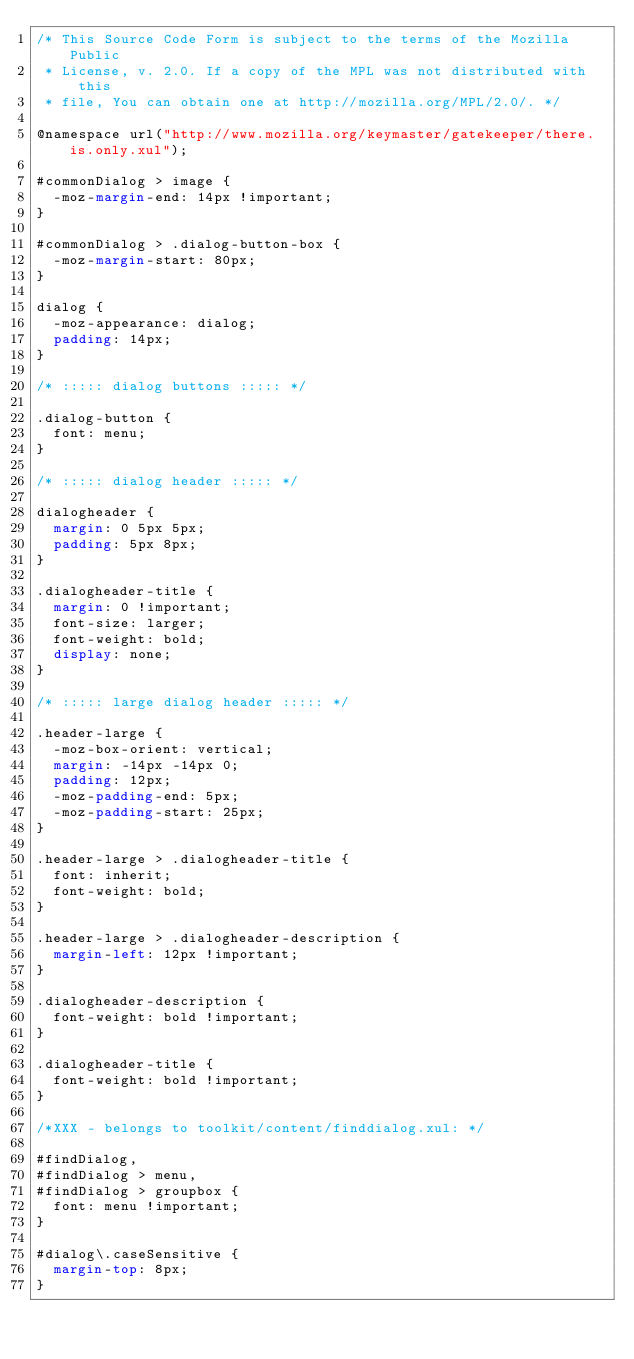<code> <loc_0><loc_0><loc_500><loc_500><_CSS_>/* This Source Code Form is subject to the terms of the Mozilla Public
 * License, v. 2.0. If a copy of the MPL was not distributed with this
 * file, You can obtain one at http://mozilla.org/MPL/2.0/. */

@namespace url("http://www.mozilla.org/keymaster/gatekeeper/there.is.only.xul");

#commonDialog > image {
  -moz-margin-end: 14px !important;
}

#commonDialog > .dialog-button-box {
  -moz-margin-start: 80px;
}

dialog { 
  -moz-appearance: dialog;
  padding: 14px;
}

/* ::::: dialog buttons ::::: */

.dialog-button {
  font: menu;
}

/* ::::: dialog header ::::: */

dialogheader {
  margin: 0 5px 5px;
  padding: 5px 8px;
}

.dialogheader-title {
  margin: 0 !important;
  font-size: larger;
  font-weight: bold;
  display: none;
}

/* ::::: large dialog header ::::: */

.header-large {
  -moz-box-orient: vertical;
  margin: -14px -14px 0;
  padding: 12px;
  -moz-padding-end: 5px;
  -moz-padding-start: 25px;
}

.header-large > .dialogheader-title {
  font: inherit;
  font-weight: bold;
}

.header-large > .dialogheader-description {
  margin-left: 12px !important;
}

.dialogheader-description {
  font-weight: bold !important;
}

.dialogheader-title {
  font-weight: bold !important;
}

/*XXX - belongs to toolkit/content/finddialog.xul: */

#findDialog,
#findDialog > menu,
#findDialog > groupbox {
  font: menu !important;
}

#dialog\.caseSensitive {
  margin-top: 8px;
}
</code> 